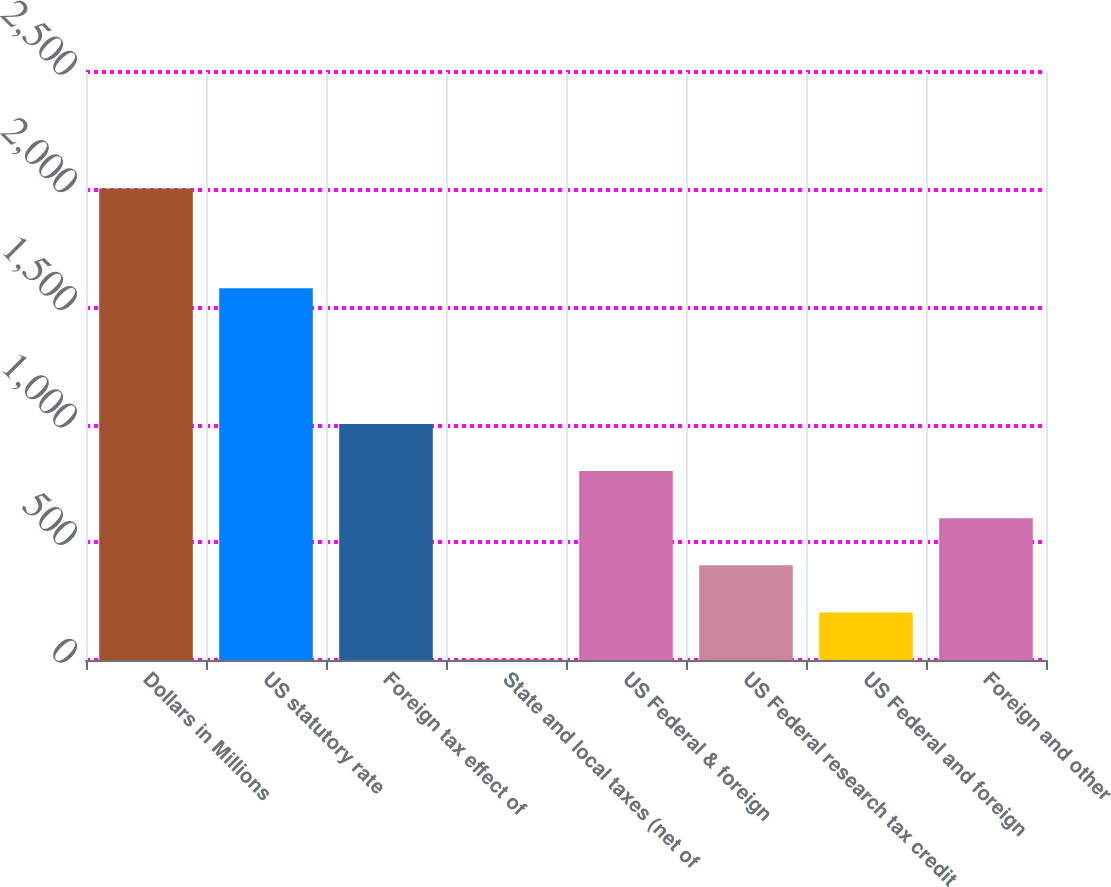Convert chart. <chart><loc_0><loc_0><loc_500><loc_500><bar_chart><fcel>Dollars in Millions<fcel>US statutory rate<fcel>Foreign tax effect of<fcel>State and local taxes (net of<fcel>US Federal & foreign<fcel>US Federal research tax credit<fcel>US Federal and foreign<fcel>Foreign and other<nl><fcel>2005<fcel>1581<fcel>1003.5<fcel>2<fcel>803.2<fcel>402.6<fcel>202.3<fcel>602.9<nl></chart> 